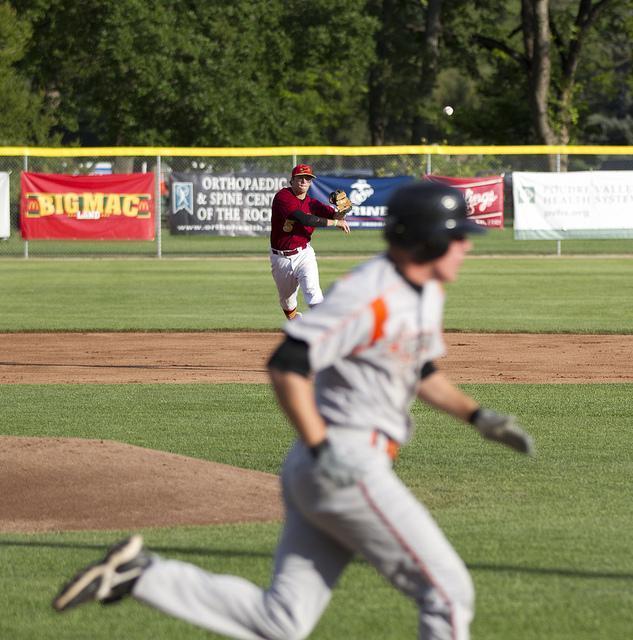How many people are there?
Give a very brief answer. 2. 